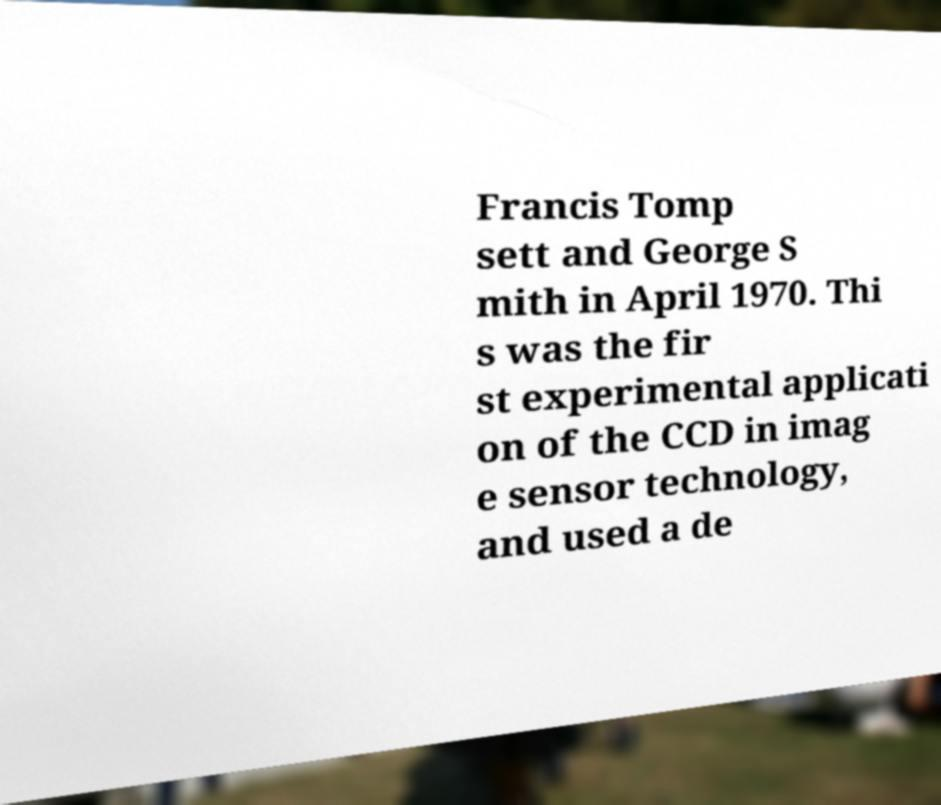I need the written content from this picture converted into text. Can you do that? Francis Tomp sett and George S mith in April 1970. Thi s was the fir st experimental applicati on of the CCD in imag e sensor technology, and used a de 